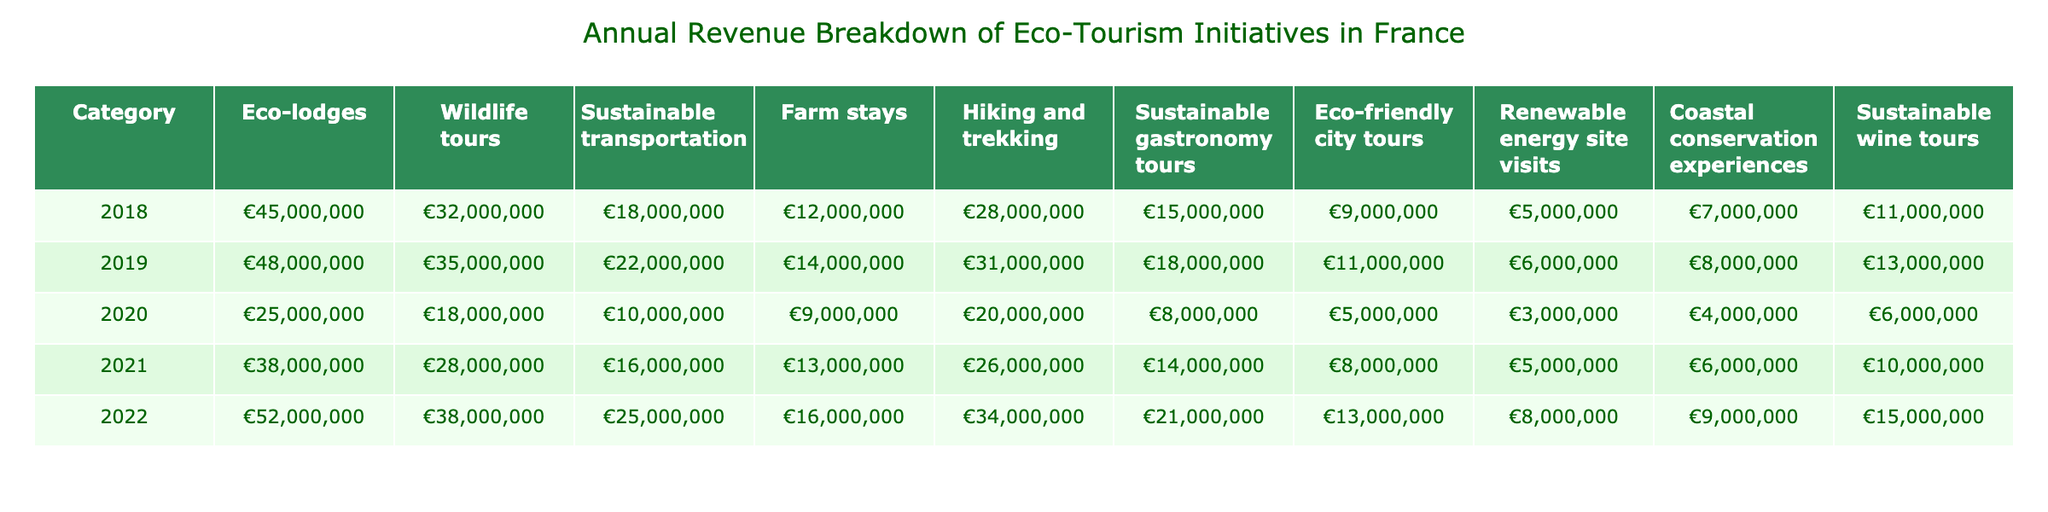What was the revenue from eco-lodges in 2020? In the table, the revenue for eco-lodges in 2020 is listed under that category for the year 2020, which shows €25,000,000.
Answer: €25,000,000 Which category had the highest revenue in 2022? Referring to the table for 2022, the category with the highest revenue is eco-lodges with €52,000,000.
Answer: Eco-lodges What is the total revenue from wildlife tours across all the years? To find the total revenue from wildlife tours, sum the amounts for each year: 32,000,000 + 35,000,000 + 18,000,000 + 28,000,000 + 38,000,000 = 151,000,000.
Answer: €151,000,000 Did the revenue from sustainable transportation increase every year from 2018 to 2022? Checking the values, sustainable transportation revenue was 18,000,000 in 2018, increased to 22,000,000 in 2019, dropped to 10,000,000 in 2020, and then increased to 16,000,000 in 2021 and 25,000,000 in 2022; it did not increase every year.
Answer: No What was the average revenue from farm stays over the five years? The revenues for farm stays are €12,000,000, €14,000,000, €9,000,000, €13,000,000, and €16,000,000. The total is 64,000,000. To find the average, divide by 5, resulting in 64,000,000 / 5 = 12,800,000.
Answer: €12,800,000 How much more revenue was generated from sustainable gastronomy tours in 2022 than in 2019? The revenue from sustainable gastronomy tours in 2022 is €21,000,000 and in 2019 is €18,000,000. The difference is 21,000,000 - 18,000,000 = 3,000,000.
Answer: €3,000,000 Which category showed the largest decrease in revenue from 2019 to 2020? Compare the revenues: wildlife tours decreased from €35,000,000 to €18,000,000 (a decrease of €17,000,000) and eco-lodges from €48,000,000 to €25,000,000 (a decrease of €23,000,000). The largest decrease is the eco-lodges category.
Answer: Eco-lodges What was the total revenue for hiking and trekking in 2021 and 2022 combined? The revenue for hiking and trekking in 2021 is €26,000,000 and in 2022 is €34,000,000. Summing these gives 26,000,000 + 34,000,000 = 60,000,000.
Answer: €60,000,000 What percentage of the total revenue in 2021 was generated by eco-friendly city tours? The total revenue in 2021 can be calculated by adding all categories: 38,000,000 + 28,000,000 + 16,000,000 + 13,000,000 + 26,000,000 + 14,000,000 + 8,000,000 + 5,000,000 + 6,000,000 + 10,000,000 =  208,000,000. The revenue from eco-friendly city tours is 8,000,000. The percentage is (8,000,000 / 208,000,000) * 100 which is approximately 3.85%.
Answer: 3.85% What was the trend in revenue for coastal conservation experiences from 2018 to 2022? Revenues were €7,000,000 in 2018, €8,000,000 in 2019, €4,000,000 in 2020, remained at €6,000,000 in 2021, and then increased to €9,000,000 in 2022. It showed fluctuations but ended higher than in 2018.
Answer: Increased overall with fluctuations 